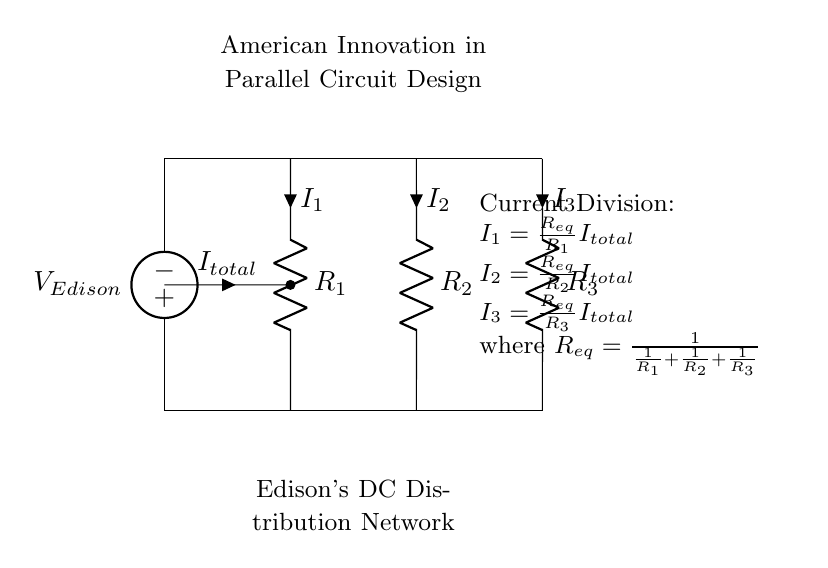What is the source voltage in the circuit? The source voltage is labeled as V_Edison. It is the voltage supplied to the entire parallel circuit.
Answer: V_Edison What are the components in the circuit? The components listed in the circuit diagram include resistors R1, R2, and R3, and a voltage source V_Edison.
Answer: R1, R2, R3, V_Edison How many branches are there in the circuit? The circuit consists of three branches, each containing one resistor.
Answer: Three What is the formula for I1? The current I1 can be calculated using the formula provided in the diagram: I1 = (R_eq/R1) * I_total, where R_eq is equivalent resistance.
Answer: I1 = (R_eq/R1) * I_total What is the equivalent resistance formula for this circuit? The equivalent resistance, R_eq, for resistors in parallel is given by the formula R_eq = 1 / (1/R1 + 1/R2 + 1/R3). This shows how total resistance is calculated for parallel resistors.
Answer: R_eq = 1 / (1/R1 + 1/R2 + 1/R3) Which current has the highest value in the circuit? To determine which current is highest, one must analyze the resistance values; lower resistance draws more current. The specific answer depends on those values, but it will be the current through the smallest resistor.
Answer: Lowest resistance current Where does the total current enter the circuit? The total current, labeled I_total, enters the circuit from the voltage source and splits into the branches defined by each resistor.
Answer: I_total enters at the source 